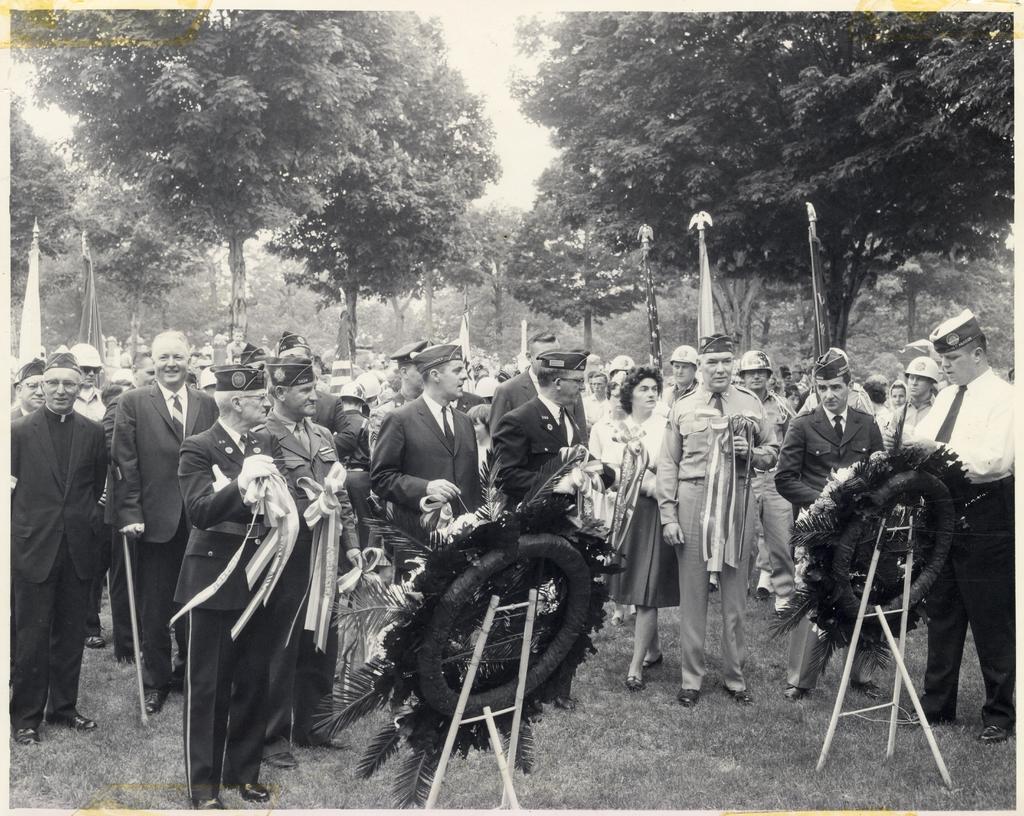Please provide a concise description of this image. This picture shows few people standing and we see trees and we see couple of garlands to the stands and we see few people wore caps on their heads and few of them holding flags in their hands. 